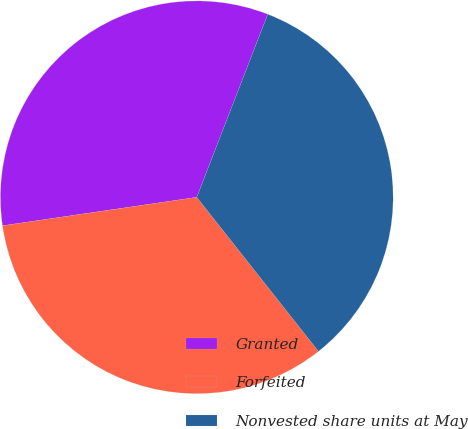<chart> <loc_0><loc_0><loc_500><loc_500><pie_chart><fcel>Granted<fcel>Forfeited<fcel>Nonvested share units at May<nl><fcel>33.2%<fcel>33.33%<fcel>33.47%<nl></chart> 